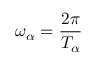<formula> <loc_0><loc_0><loc_500><loc_500>\omega _ { \alpha } = \frac { 2 \pi } { T _ { \alpha } }</formula> 